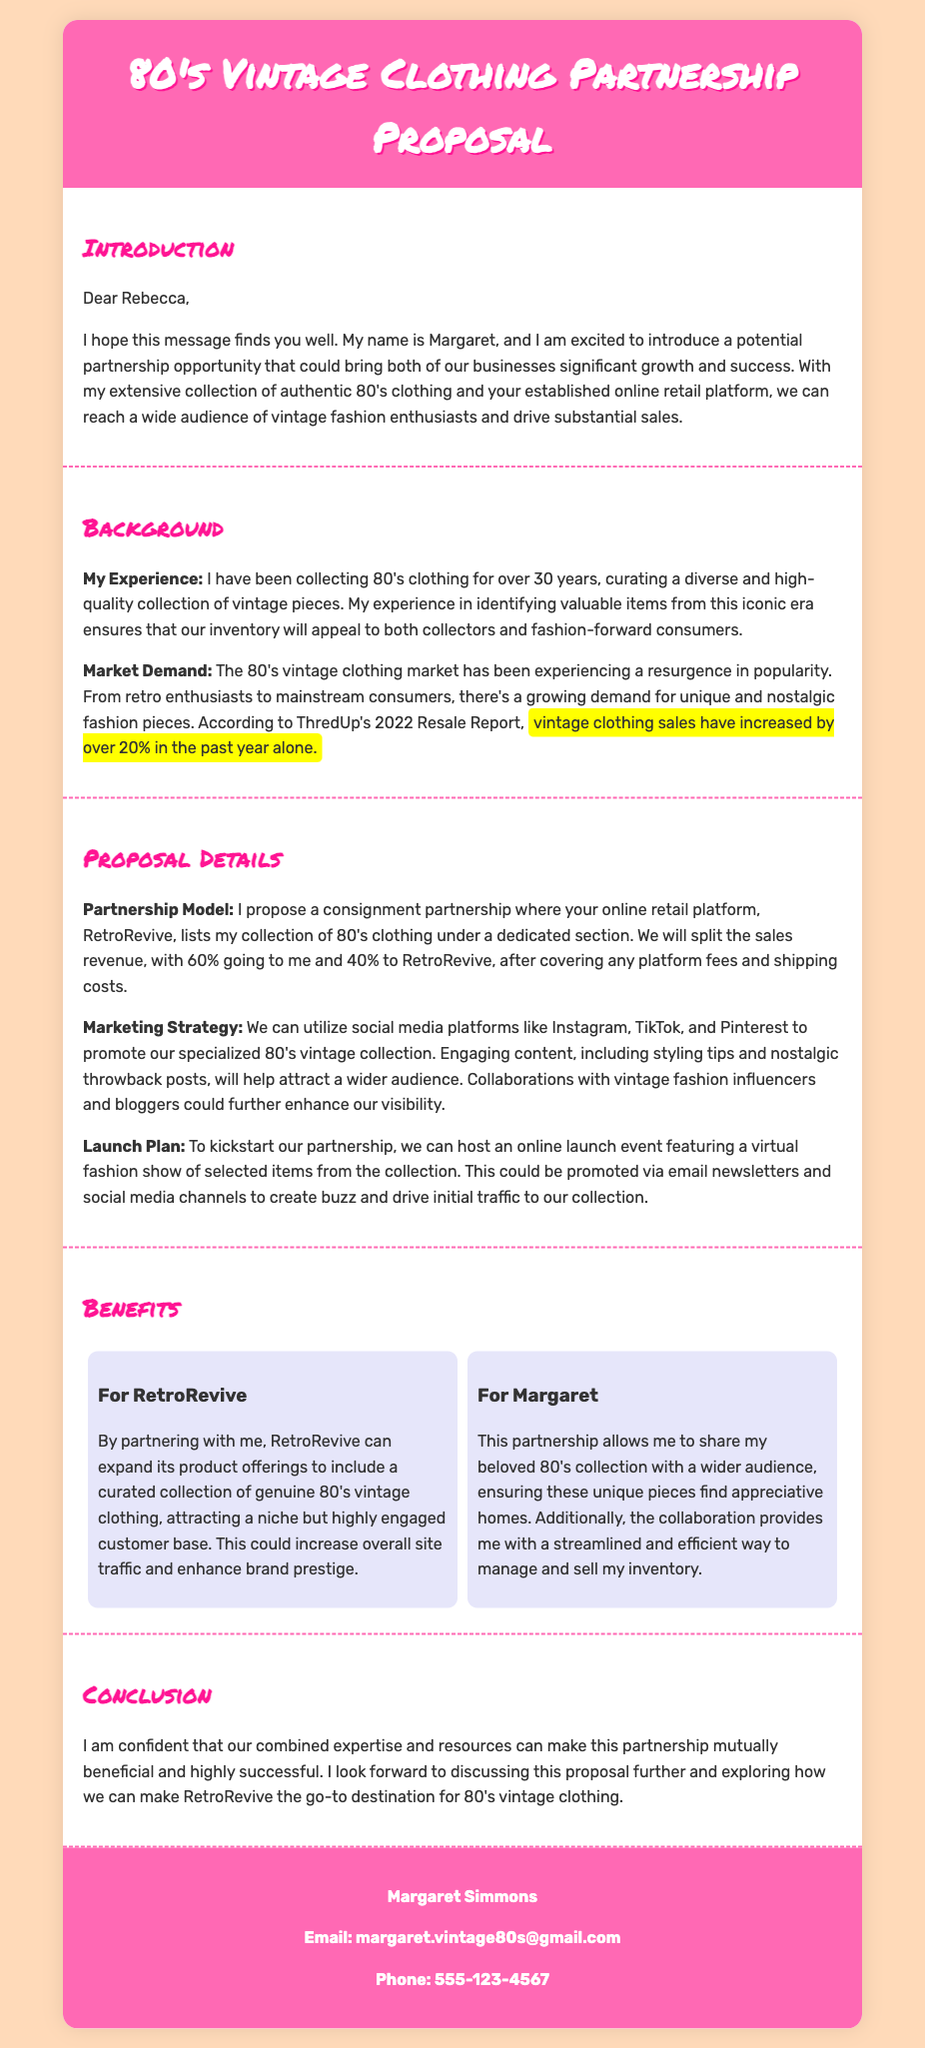What is the name of the proposer? The name of the proposer is stated at the end of the document, which is Margaret Simmons.
Answer: Margaret Simmons What is the main market focus of the proposal? The document specifies the focus on selling 80's vintage clothing, highlighting the growing demand for this niche.
Answer: 80's vintage clothing What percentage of sales revenue will go to Margaret? The proposal details the split in sales revenue where 60% is allocated to Margaret.
Answer: 60% What marketing strategy is proposed? The document outlines the use of social media platforms like Instagram, TikTok, and Pinterest to promote the collection.
Answer: Social media How long has Margaret been collecting 80's clothing? The document mentions that Margaret has been collecting for over 30 years.
Answer: 30 years What is the proposed partnership model? The document describes a consignment partnership as the proposed model for the collaboration.
Answer: Consignment What is one benefit for RetroRevive mentioned in the proposal? The proposal lists expansion of product offerings as a benefit for RetroRevive.
Answer: Expansion of product offerings What event is proposed to launch the partnership? The document mentions hosting an online launch event featuring a virtual fashion show.
Answer: Virtual fashion show Where is the contact information situated in the document? Contact information is located in the contact info section at the end of the proposal.
Answer: End of the proposal 